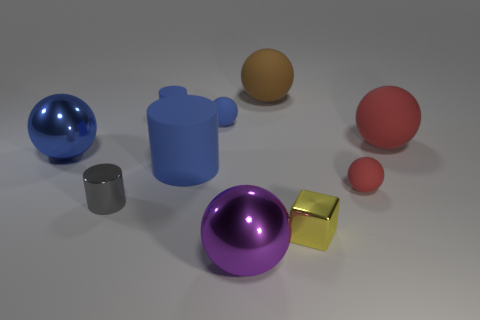There is a blue rubber object on the right side of the big rubber thing to the left of the big matte sphere that is left of the shiny block; what size is it?
Your response must be concise. Small. How many objects are balls that are behind the small blue rubber cylinder or gray things?
Make the answer very short. 2. There is a rubber sphere to the left of the purple metal ball; what number of tiny cylinders are behind it?
Your answer should be very brief. 1. Is the number of big metallic things on the right side of the blue metal thing greater than the number of small red balls?
Provide a succinct answer. No. What is the size of the object that is in front of the metal cylinder and behind the purple sphere?
Give a very brief answer. Small. The metal thing that is in front of the tiny red thing and left of the large purple object has what shape?
Ensure brevity in your answer.  Cylinder. Are there any small red balls left of the ball that is in front of the tiny rubber thing to the right of the yellow shiny cube?
Ensure brevity in your answer.  No. How many things are either big metal objects behind the tiny red sphere or large shiny balls behind the big purple metallic object?
Offer a terse response. 1. Does the tiny yellow cube that is in front of the blue matte sphere have the same material as the small red sphere?
Your response must be concise. No. What material is the object that is in front of the large cylinder and to the right of the tiny yellow object?
Your answer should be compact. Rubber. 